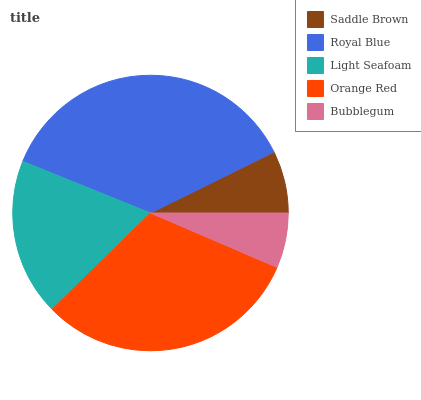Is Bubblegum the minimum?
Answer yes or no. Yes. Is Royal Blue the maximum?
Answer yes or no. Yes. Is Light Seafoam the minimum?
Answer yes or no. No. Is Light Seafoam the maximum?
Answer yes or no. No. Is Royal Blue greater than Light Seafoam?
Answer yes or no. Yes. Is Light Seafoam less than Royal Blue?
Answer yes or no. Yes. Is Light Seafoam greater than Royal Blue?
Answer yes or no. No. Is Royal Blue less than Light Seafoam?
Answer yes or no. No. Is Light Seafoam the high median?
Answer yes or no. Yes. Is Light Seafoam the low median?
Answer yes or no. Yes. Is Saddle Brown the high median?
Answer yes or no. No. Is Royal Blue the low median?
Answer yes or no. No. 